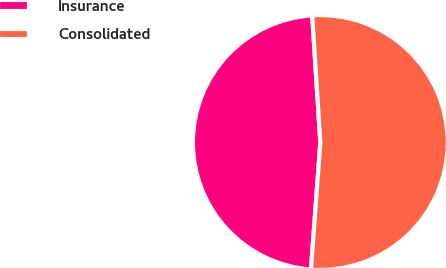Convert chart to OTSL. <chart><loc_0><loc_0><loc_500><loc_500><pie_chart><fcel>Insurance<fcel>Consolidated<nl><fcel>47.81%<fcel>52.19%<nl></chart> 